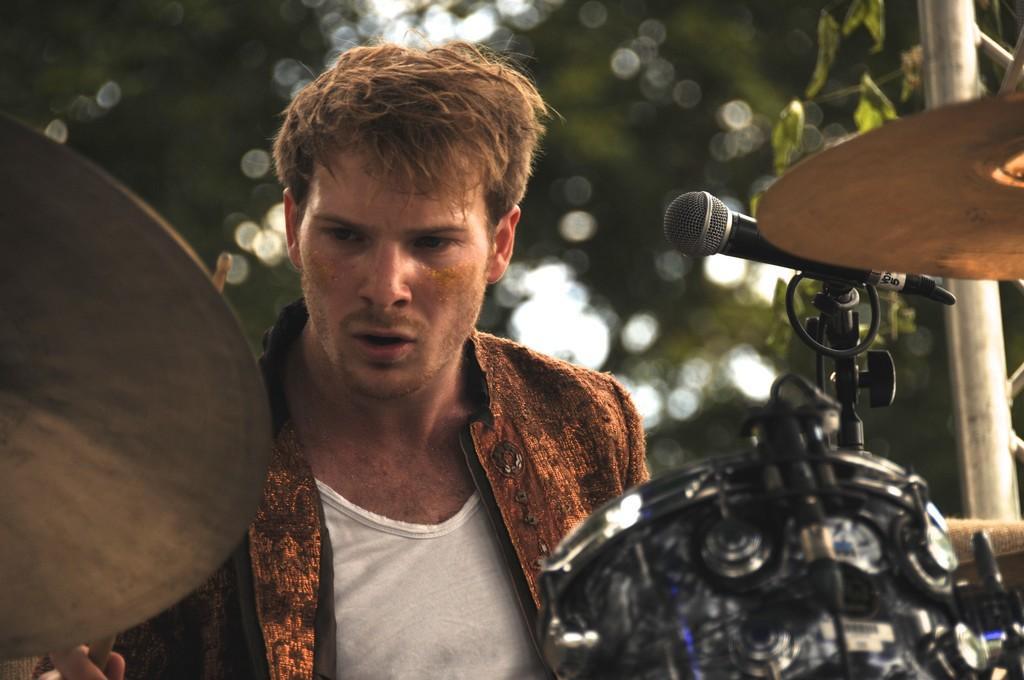In one or two sentences, can you explain what this image depicts? Here I can see a man wearing a jacket. It seems like this person is playing the drums. There is a stick in his right hand. In the background few leaves are visible. On the right side there is a mike stand. 